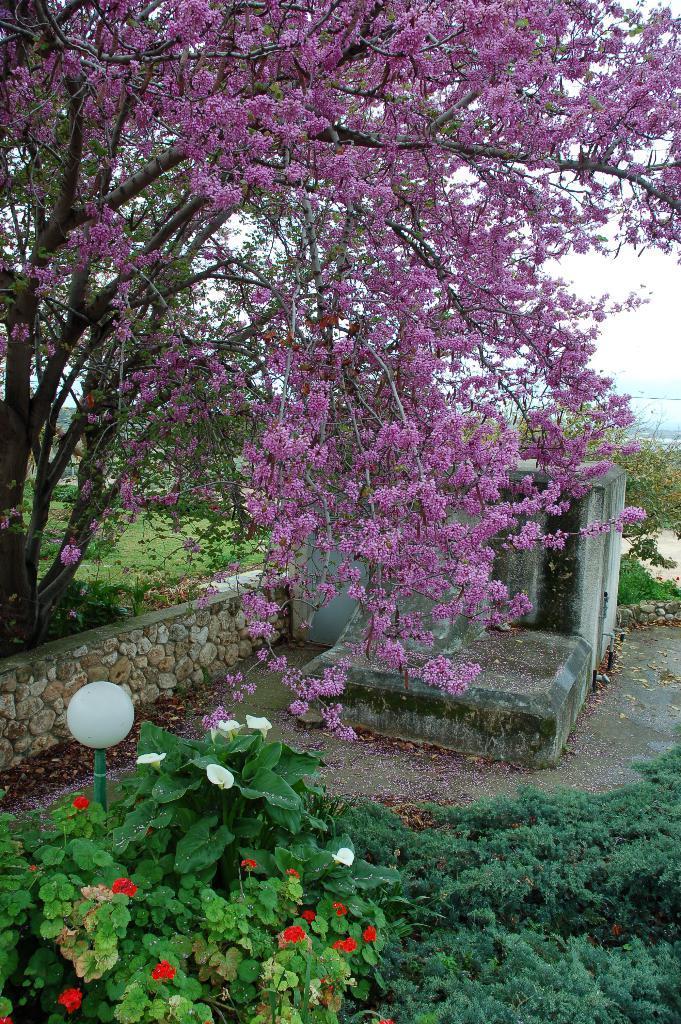Can you describe this image briefly? In this image there are flowers, trees, plants, lamp, wall and a building. In the background there is the sky. 